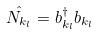Convert formula to latex. <formula><loc_0><loc_0><loc_500><loc_500>\hat { N _ { k _ { l } } } = b _ { k _ { l } } ^ { \dagger } b _ { k _ { l } }</formula> 